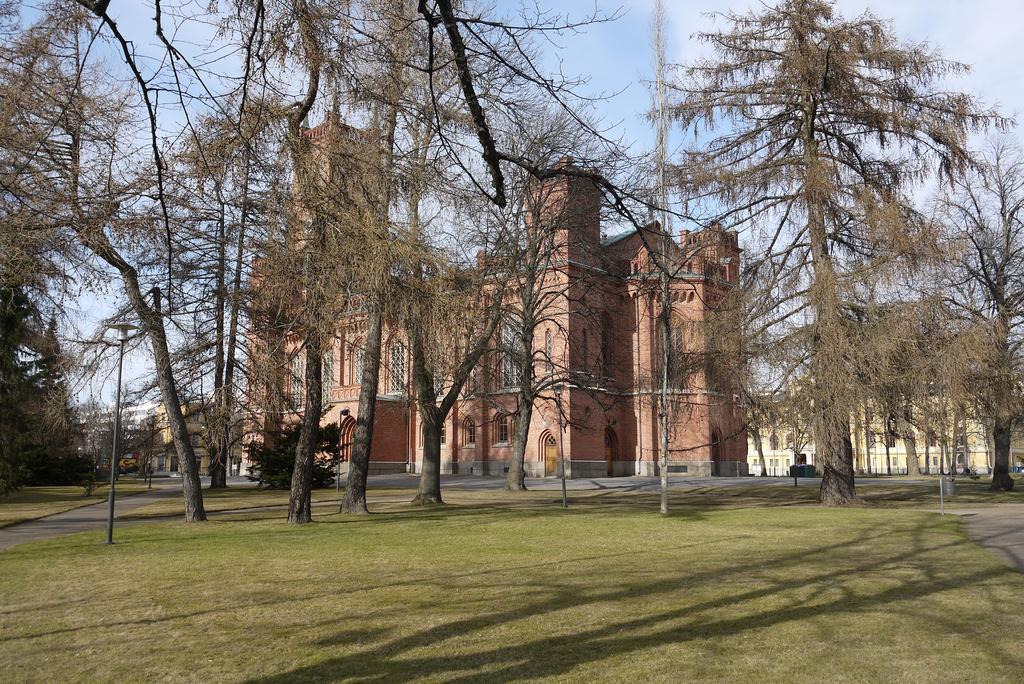Describe this image in one or two sentences. This picture shows a few buildings and we see trees and grass on the ground and we see couple of pole lights and a blue cloudy Sky. 